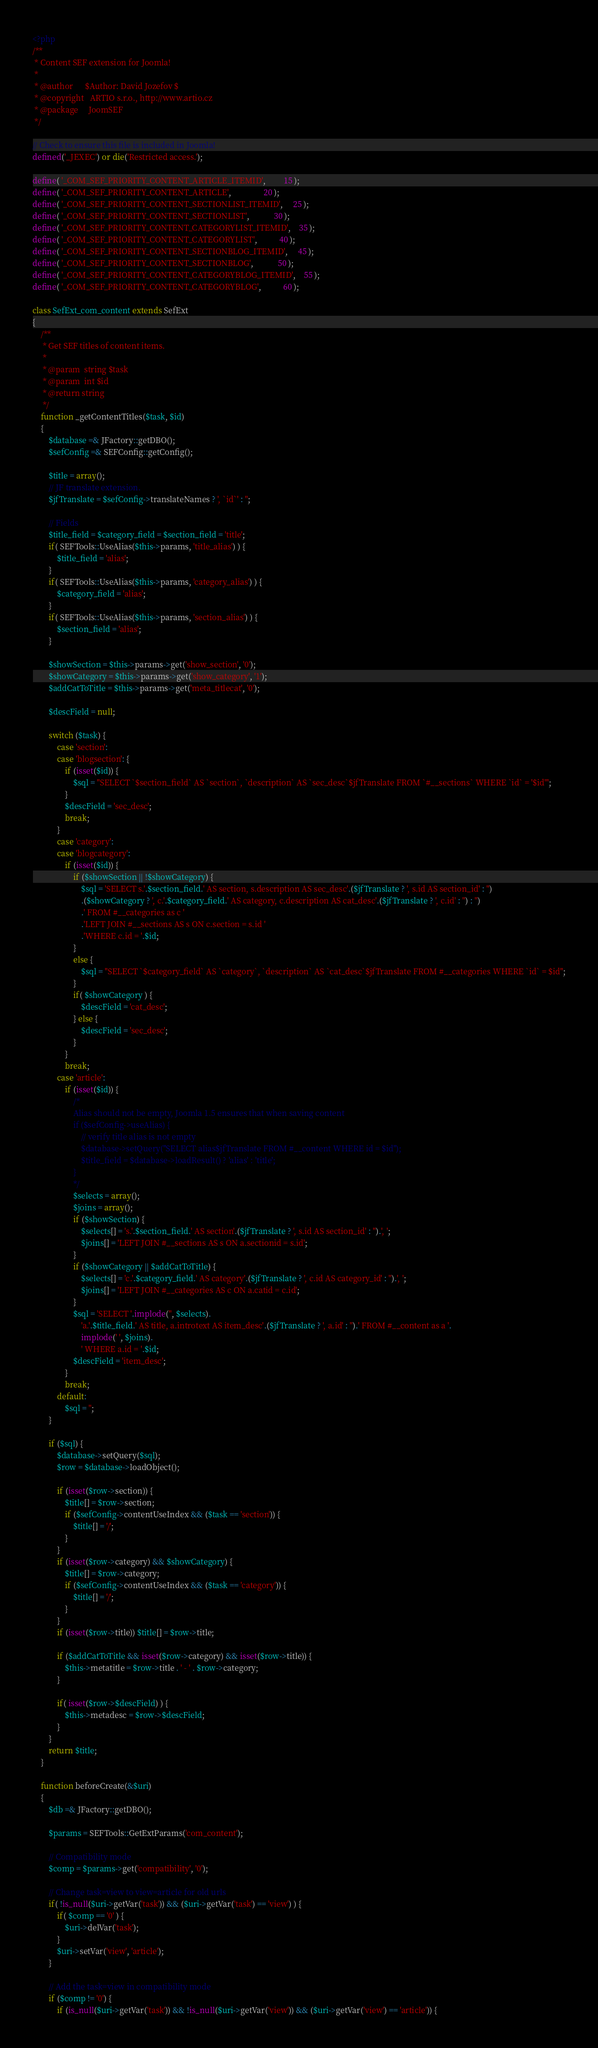<code> <loc_0><loc_0><loc_500><loc_500><_PHP_><?php
/**
 * Content SEF extension for Joomla!
 *
 * @author      $Author: David Jozefov $
 * @copyright   ARTIO s.r.o., http://www.artio.cz
 * @package     JoomSEF
 */

// Check to ensure this file is included in Joomla!
defined('_JEXEC') or die('Restricted access.');

define( '_COM_SEF_PRIORITY_CONTENT_ARTICLE_ITEMID',         15 );
define( '_COM_SEF_PRIORITY_CONTENT_ARTICLE',                20 );
define( '_COM_SEF_PRIORITY_CONTENT_SECTIONLIST_ITEMID',     25 );
define( '_COM_SEF_PRIORITY_CONTENT_SECTIONLIST',            30 );
define( '_COM_SEF_PRIORITY_CONTENT_CATEGORYLIST_ITEMID',    35 );
define( '_COM_SEF_PRIORITY_CONTENT_CATEGORYLIST',           40 );
define( '_COM_SEF_PRIORITY_CONTENT_SECTIONBLOG_ITEMID',     45 );
define( '_COM_SEF_PRIORITY_CONTENT_SECTIONBLOG',            50 );
define( '_COM_SEF_PRIORITY_CONTENT_CATEGORYBLOG_ITEMID',    55 );
define( '_COM_SEF_PRIORITY_CONTENT_CATEGORYBLOG',           60 );

class SefExt_com_content extends SefExt
{
    /**
     * Get SEF titles of content items.
     *
     * @param  string $task
     * @param  int $id
     * @return string
     */
    function _getContentTitles($task, $id)
    {
        $database =& JFactory::getDBO();
        $sefConfig =& SEFConfig::getConfig();

        $title = array();
        // JF translate extension.
        $jfTranslate = $sefConfig->translateNames ? ', `id`' : '';
        
        // Fields
        $title_field = $category_field = $section_field = 'title';
        if( SEFTools::UseAlias($this->params, 'title_alias') ) {
            $title_field = 'alias';
        }
        if( SEFTools::UseAlias($this->params, 'category_alias') ) {
            $category_field = 'alias';
        }
        if( SEFTools::UseAlias($this->params, 'section_alias') ) {
            $section_field = 'alias';
        }
        
        $showSection = $this->params->get('show_section', '0');
        $showCategory = $this->params->get('show_category', '1');
        $addCatToTitle = $this->params->get('meta_titlecat', '0');

        $descField = null;
        
        switch ($task) {
            case 'section':
            case 'blogsection': {
                if (isset($id)) {
                    $sql = "SELECT `$section_field` AS `section`, `description` AS `sec_desc`$jfTranslate FROM `#__sections` WHERE `id` = '$id'";
                }
                $descField = 'sec_desc';
                break;
            }
            case 'category':
            case 'blogcategory':
                if (isset($id)) {
                    if ($showSection || !$showCategory) {
                        $sql = 'SELECT s.'.$section_field.' AS section, s.description AS sec_desc'.($jfTranslate ? ', s.id AS section_id' : '')
                        .($showCategory ? ', c.'.$category_field.' AS category, c.description AS cat_desc'.($jfTranslate ? ', c.id' : '') : '')
                        .' FROM #__categories as c '
                        .'LEFT JOIN #__sections AS s ON c.section = s.id '
                        .'WHERE c.id = '.$id;
                    }
                    else {
                        $sql = "SELECT `$category_field` AS `category`, `description` AS `cat_desc`$jfTranslate FROM #__categories WHERE `id` = $id";
                    }
                    if( $showCategory ) {
                        $descField = 'cat_desc';
                    } else {
                        $descField = 'sec_desc';
                    }
                }
                break;
            case 'article':
                if (isset($id)) {
                    /*
                    Alias should not be empty, Joomla 1.5 ensures that when saving content
                    if ($sefConfig->useAlias) {
                        // verify title alias is not empty
                        $database->setQuery("SELECT alias$jfTranslate FROM #__content WHERE id = $id");
                        $title_field = $database->loadResult() ? 'alias' : 'title';
                    }
                    */
                    $selects = array();
                    $joins = array();
                    if ($showSection) {
                        $selects[] = 's.'.$section_field.' AS section'.($jfTranslate ? ', s.id AS section_id' : '').', ';
                        $joins[] = 'LEFT JOIN #__sections AS s ON a.sectionid = s.id';
                    }
                    if ($showCategory || $addCatToTitle) {
                        $selects[] = 'c.'.$category_field.' AS category'.($jfTranslate ? ', c.id AS category_id' : '').', ';
                        $joins[] = 'LEFT JOIN #__categories AS c ON a.catid = c.id';
                    }
                    $sql = 'SELECT '.implode('', $selects).
                        'a.'.$title_field.' AS title, a.introtext AS item_desc'.($jfTranslate ? ', a.id' : '').' FROM #__content as a '.
                        implode(' ', $joins).
                        ' WHERE a.id = '.$id;
                    $descField = 'item_desc';
                }
                break;
            default:
                $sql = '';
        }

        if ($sql) {
            $database->setQuery($sql);
            $row = $database->loadObject();

            if (isset($row->section)) {
                $title[] = $row->section;
                if ($sefConfig->contentUseIndex && ($task == 'section')) {
                    $title[] = '/';
                }
            }
            if (isset($row->category) && $showCategory) {
                $title[] = $row->category;
                if ($sefConfig->contentUseIndex && ($task == 'category')) {
                    $title[] = '/';
                }
            }
            if (isset($row->title)) $title[] = $row->title;
            
            if ($addCatToTitle && isset($row->category) && isset($row->title)) {
                $this->metatitle = $row->title . ' - ' . $row->category;
            }
            
            if( isset($row->$descField) ) {
                $this->metadesc = $row->$descField;
            }
        }
        return $title;
    }

    function beforeCreate(&$uri)
    {
        $db =& JFactory::getDBO();

        $params = SEFTools::GetExtParams('com_content');

        // Compatibility mode
        $comp = $params->get('compatibility', '0');
        
        // Change task=view to view=article for old urls
        if( !is_null($uri->getVar('task')) && ($uri->getVar('task') == 'view') ) {
            if( $comp == '0' ) {
                $uri->delVar('task');
            }
            $uri->setVar('view', 'article');
        }
        
        // Add the task=view in compatibility mode
        if ($comp != '0') {
            if (is_null($uri->getVar('task')) && !is_null($uri->getVar('view')) && ($uri->getVar('view') == 'article')) {</code> 